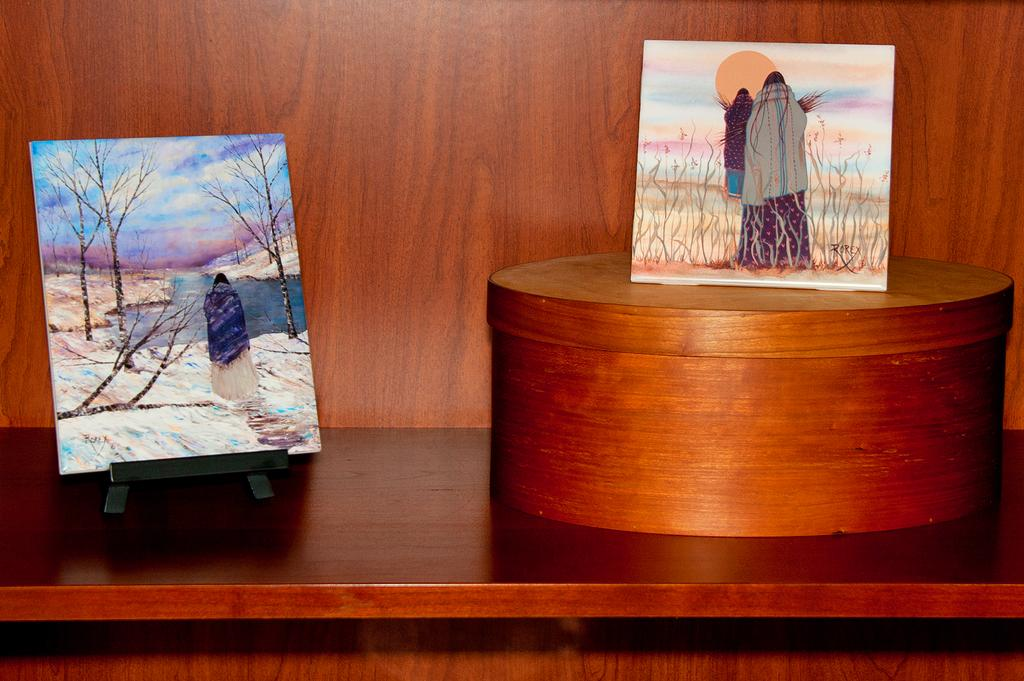How many paintings are visible in the image? There are two paintings in the image. What is depicted in the painting on the left side? The painting on the left side depicts trees, water, and the sky. What is shown in the painting on the right side? The painting on the right side depicts plants and two persons. Can you hear the bell ringing in the image? There is no bell present in the image, so it cannot be heard. 